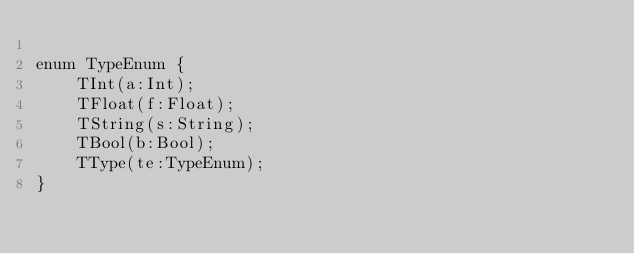<code> <loc_0><loc_0><loc_500><loc_500><_Haxe_>
enum TypeEnum {
	TInt(a:Int);
	TFloat(f:Float);
	TString(s:String);
	TBool(b:Bool);
	TType(te:TypeEnum);
}
</code> 